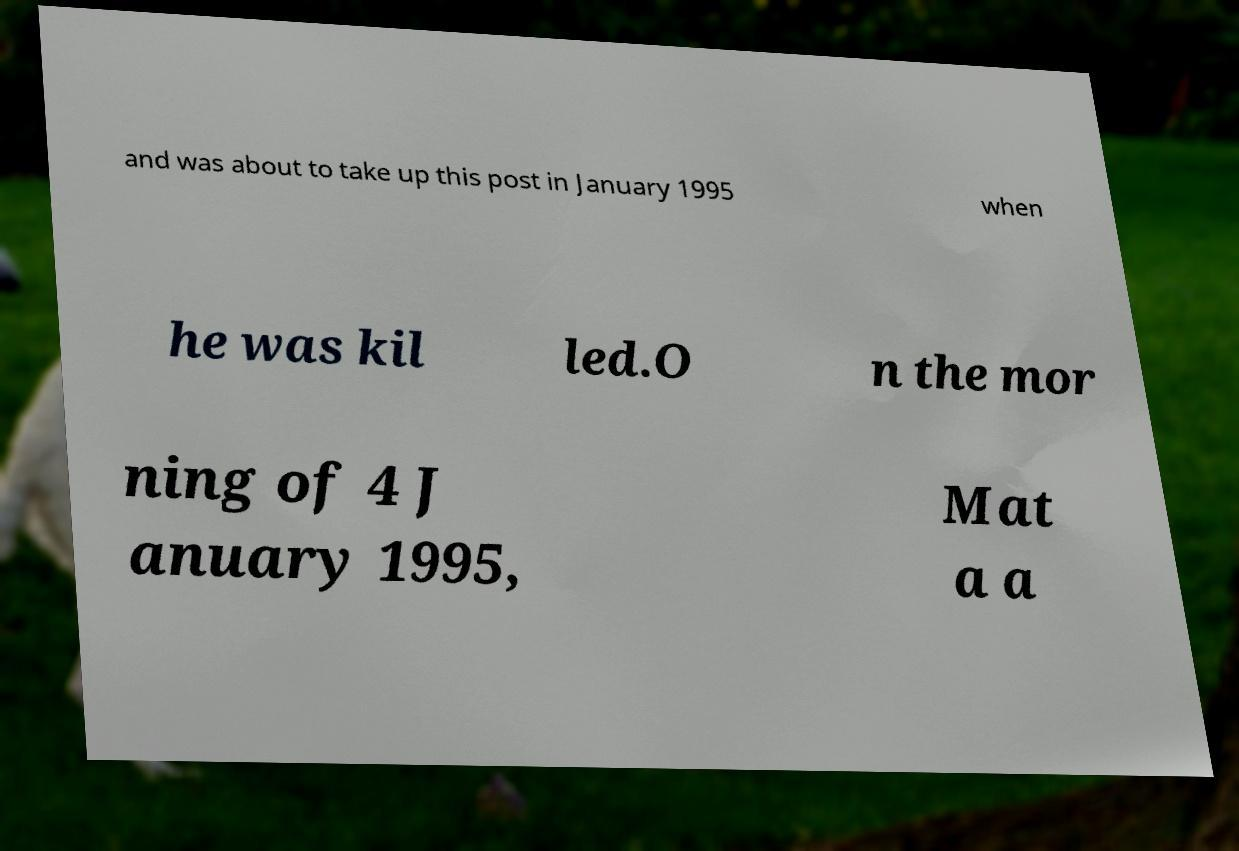What messages or text are displayed in this image? I need them in a readable, typed format. and was about to take up this post in January 1995 when he was kil led.O n the mor ning of 4 J anuary 1995, Mat a a 